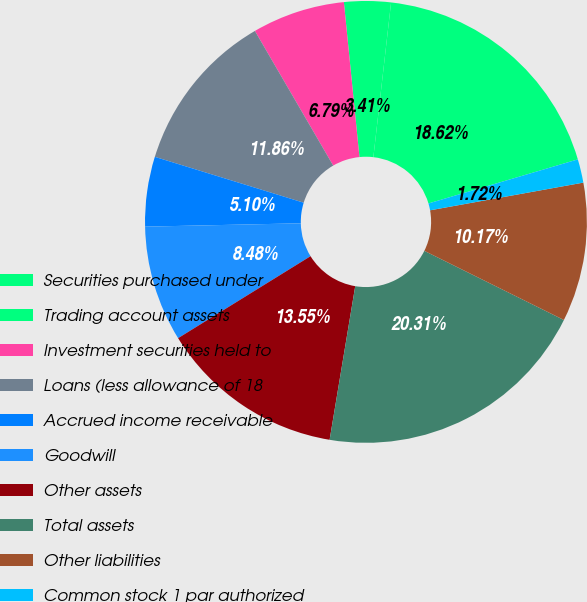Convert chart. <chart><loc_0><loc_0><loc_500><loc_500><pie_chart><fcel>Securities purchased under<fcel>Trading account assets<fcel>Investment securities held to<fcel>Loans (less allowance of 18<fcel>Accrued income receivable<fcel>Goodwill<fcel>Other assets<fcel>Total assets<fcel>Other liabilities<fcel>Common stock 1 par authorized<nl><fcel>18.62%<fcel>3.41%<fcel>6.79%<fcel>11.86%<fcel>5.1%<fcel>8.48%<fcel>13.55%<fcel>20.31%<fcel>10.17%<fcel>1.72%<nl></chart> 